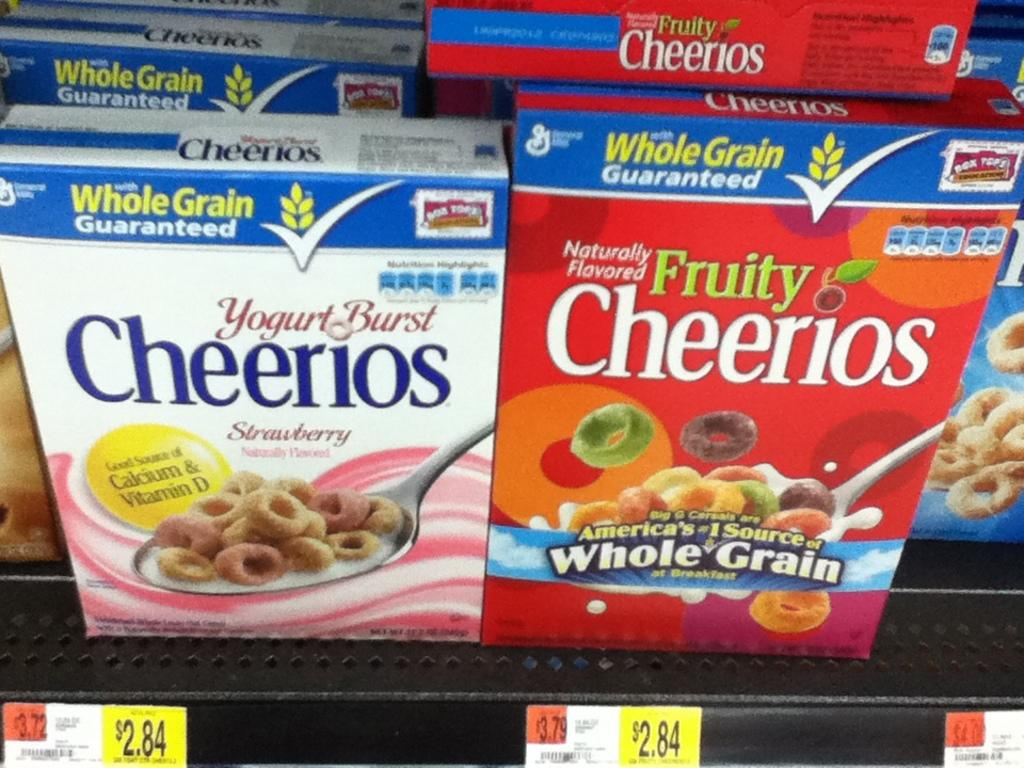What type of items can be seen in the image? There are boxes of food items in the image. Where are the food items located? The food items are on a rack. Are there any additional elements in the image related to the food items? Yes, there are price boards in the image. What type of fowl can be seen on the rack in the image? There is no fowl present on the rack in the image; it contains only boxes of food items. What type of blade is being used to cut the food items in the image? There is no blade visible in the image, and no food items are being cut. 